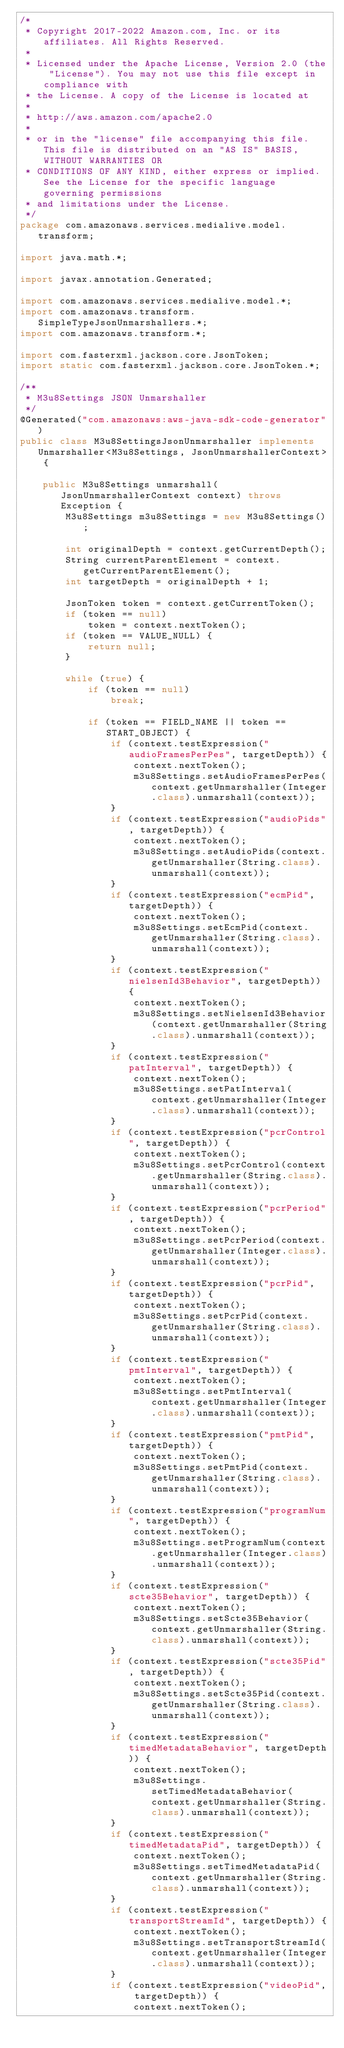<code> <loc_0><loc_0><loc_500><loc_500><_Java_>/*
 * Copyright 2017-2022 Amazon.com, Inc. or its affiliates. All Rights Reserved.
 * 
 * Licensed under the Apache License, Version 2.0 (the "License"). You may not use this file except in compliance with
 * the License. A copy of the License is located at
 * 
 * http://aws.amazon.com/apache2.0
 * 
 * or in the "license" file accompanying this file. This file is distributed on an "AS IS" BASIS, WITHOUT WARRANTIES OR
 * CONDITIONS OF ANY KIND, either express or implied. See the License for the specific language governing permissions
 * and limitations under the License.
 */
package com.amazonaws.services.medialive.model.transform;

import java.math.*;

import javax.annotation.Generated;

import com.amazonaws.services.medialive.model.*;
import com.amazonaws.transform.SimpleTypeJsonUnmarshallers.*;
import com.amazonaws.transform.*;

import com.fasterxml.jackson.core.JsonToken;
import static com.fasterxml.jackson.core.JsonToken.*;

/**
 * M3u8Settings JSON Unmarshaller
 */
@Generated("com.amazonaws:aws-java-sdk-code-generator")
public class M3u8SettingsJsonUnmarshaller implements Unmarshaller<M3u8Settings, JsonUnmarshallerContext> {

    public M3u8Settings unmarshall(JsonUnmarshallerContext context) throws Exception {
        M3u8Settings m3u8Settings = new M3u8Settings();

        int originalDepth = context.getCurrentDepth();
        String currentParentElement = context.getCurrentParentElement();
        int targetDepth = originalDepth + 1;

        JsonToken token = context.getCurrentToken();
        if (token == null)
            token = context.nextToken();
        if (token == VALUE_NULL) {
            return null;
        }

        while (true) {
            if (token == null)
                break;

            if (token == FIELD_NAME || token == START_OBJECT) {
                if (context.testExpression("audioFramesPerPes", targetDepth)) {
                    context.nextToken();
                    m3u8Settings.setAudioFramesPerPes(context.getUnmarshaller(Integer.class).unmarshall(context));
                }
                if (context.testExpression("audioPids", targetDepth)) {
                    context.nextToken();
                    m3u8Settings.setAudioPids(context.getUnmarshaller(String.class).unmarshall(context));
                }
                if (context.testExpression("ecmPid", targetDepth)) {
                    context.nextToken();
                    m3u8Settings.setEcmPid(context.getUnmarshaller(String.class).unmarshall(context));
                }
                if (context.testExpression("nielsenId3Behavior", targetDepth)) {
                    context.nextToken();
                    m3u8Settings.setNielsenId3Behavior(context.getUnmarshaller(String.class).unmarshall(context));
                }
                if (context.testExpression("patInterval", targetDepth)) {
                    context.nextToken();
                    m3u8Settings.setPatInterval(context.getUnmarshaller(Integer.class).unmarshall(context));
                }
                if (context.testExpression("pcrControl", targetDepth)) {
                    context.nextToken();
                    m3u8Settings.setPcrControl(context.getUnmarshaller(String.class).unmarshall(context));
                }
                if (context.testExpression("pcrPeriod", targetDepth)) {
                    context.nextToken();
                    m3u8Settings.setPcrPeriod(context.getUnmarshaller(Integer.class).unmarshall(context));
                }
                if (context.testExpression("pcrPid", targetDepth)) {
                    context.nextToken();
                    m3u8Settings.setPcrPid(context.getUnmarshaller(String.class).unmarshall(context));
                }
                if (context.testExpression("pmtInterval", targetDepth)) {
                    context.nextToken();
                    m3u8Settings.setPmtInterval(context.getUnmarshaller(Integer.class).unmarshall(context));
                }
                if (context.testExpression("pmtPid", targetDepth)) {
                    context.nextToken();
                    m3u8Settings.setPmtPid(context.getUnmarshaller(String.class).unmarshall(context));
                }
                if (context.testExpression("programNum", targetDepth)) {
                    context.nextToken();
                    m3u8Settings.setProgramNum(context.getUnmarshaller(Integer.class).unmarshall(context));
                }
                if (context.testExpression("scte35Behavior", targetDepth)) {
                    context.nextToken();
                    m3u8Settings.setScte35Behavior(context.getUnmarshaller(String.class).unmarshall(context));
                }
                if (context.testExpression("scte35Pid", targetDepth)) {
                    context.nextToken();
                    m3u8Settings.setScte35Pid(context.getUnmarshaller(String.class).unmarshall(context));
                }
                if (context.testExpression("timedMetadataBehavior", targetDepth)) {
                    context.nextToken();
                    m3u8Settings.setTimedMetadataBehavior(context.getUnmarshaller(String.class).unmarshall(context));
                }
                if (context.testExpression("timedMetadataPid", targetDepth)) {
                    context.nextToken();
                    m3u8Settings.setTimedMetadataPid(context.getUnmarshaller(String.class).unmarshall(context));
                }
                if (context.testExpression("transportStreamId", targetDepth)) {
                    context.nextToken();
                    m3u8Settings.setTransportStreamId(context.getUnmarshaller(Integer.class).unmarshall(context));
                }
                if (context.testExpression("videoPid", targetDepth)) {
                    context.nextToken();</code> 